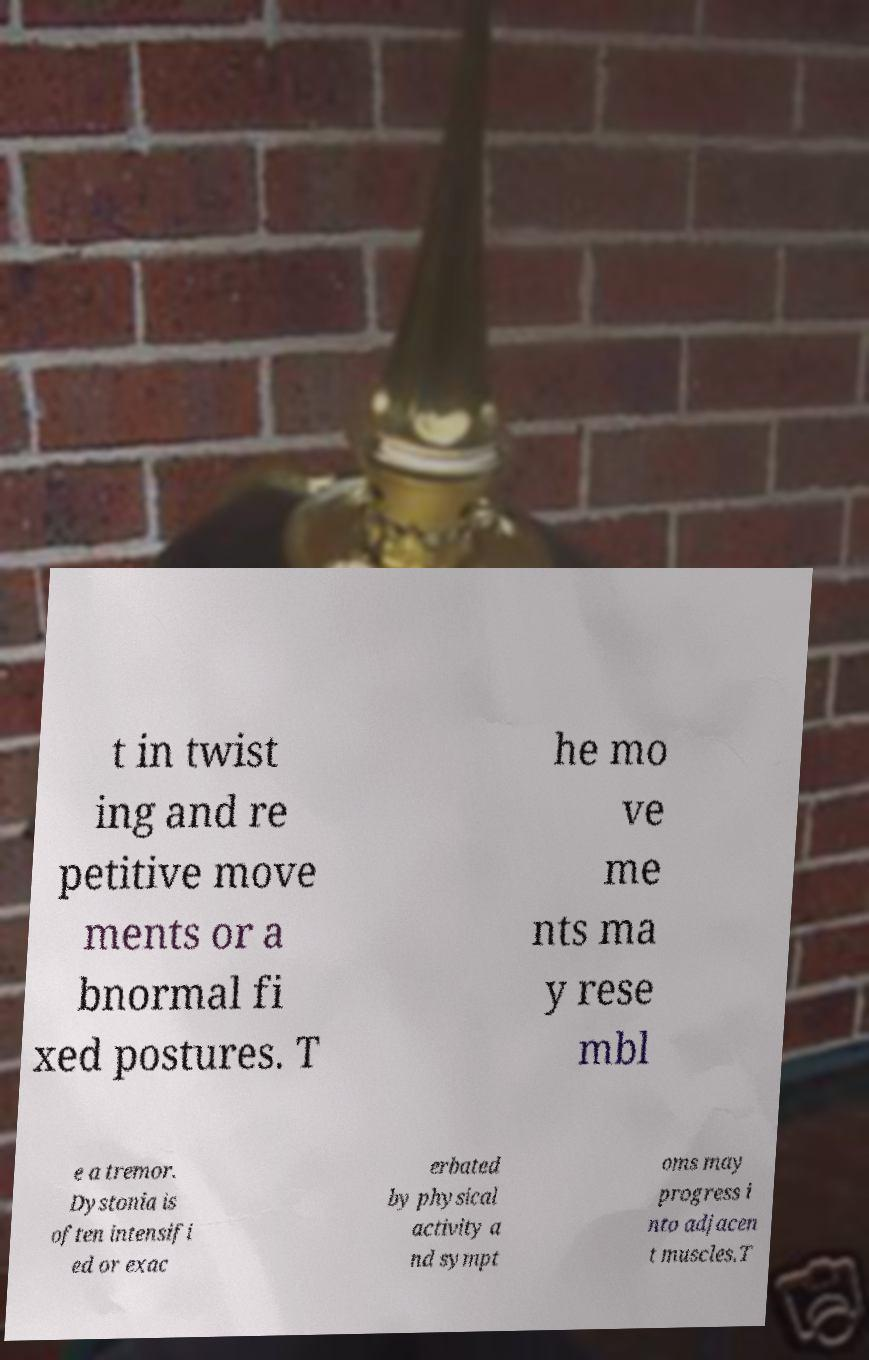Please identify and transcribe the text found in this image. t in twist ing and re petitive move ments or a bnormal fi xed postures. T he mo ve me nts ma y rese mbl e a tremor. Dystonia is often intensifi ed or exac erbated by physical activity a nd sympt oms may progress i nto adjacen t muscles.T 